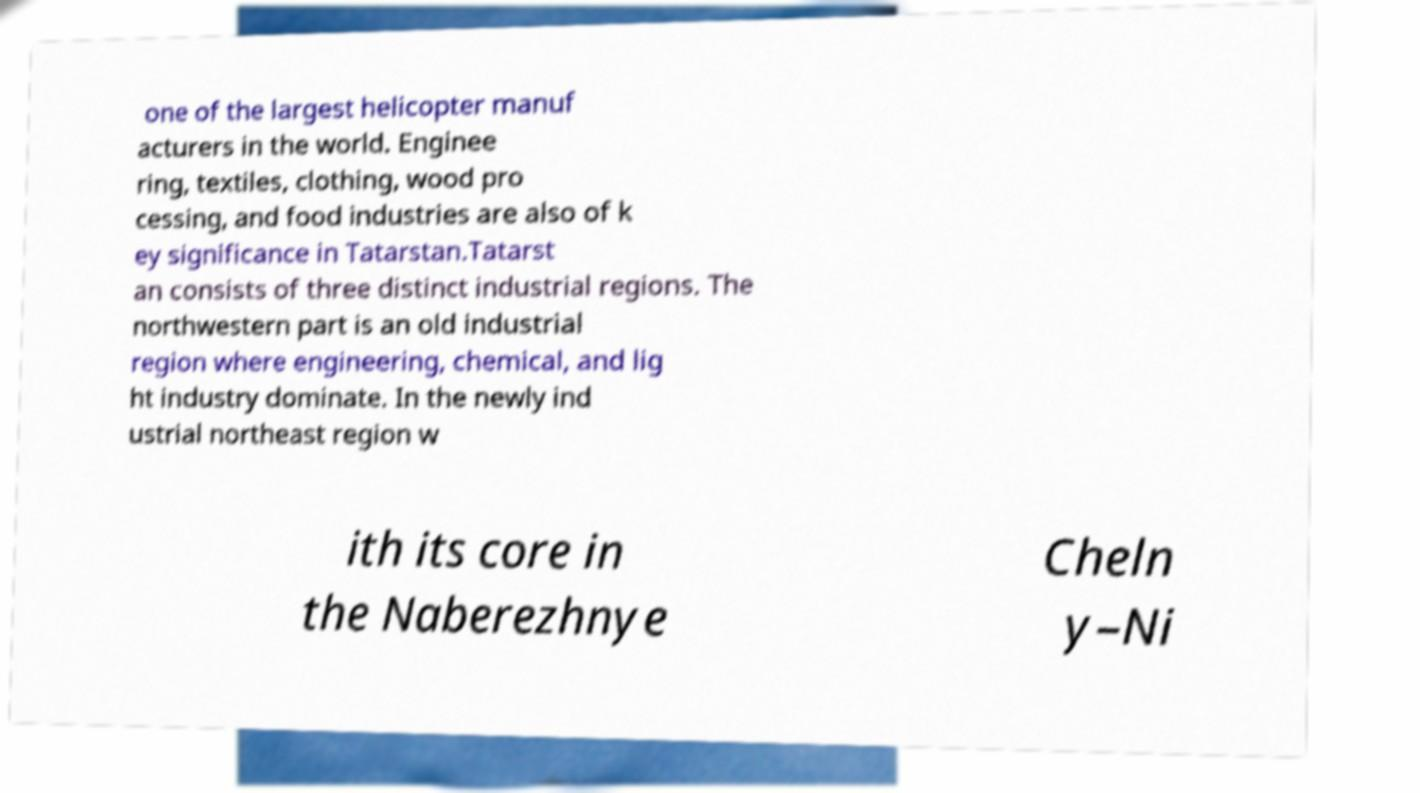Please read and relay the text visible in this image. What does it say? one of the largest helicopter manuf acturers in the world. Enginee ring, textiles, clothing, wood pro cessing, and food industries are also of k ey significance in Tatarstan.Tatarst an consists of three distinct industrial regions. The northwestern part is an old industrial region where engineering, chemical, and lig ht industry dominate. In the newly ind ustrial northeast region w ith its core in the Naberezhnye Cheln y–Ni 